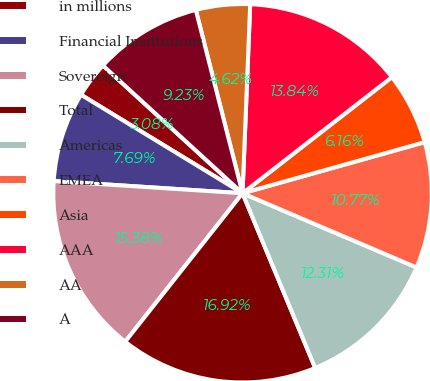Convert chart. <chart><loc_0><loc_0><loc_500><loc_500><pie_chart><fcel>in millions<fcel>Financial Institutions<fcel>Sovereign<fcel>Total<fcel>Americas<fcel>EMEA<fcel>Asia<fcel>AAA<fcel>AA<fcel>A<nl><fcel>3.08%<fcel>7.69%<fcel>15.38%<fcel>16.92%<fcel>12.31%<fcel>10.77%<fcel>6.16%<fcel>13.84%<fcel>4.62%<fcel>9.23%<nl></chart> 